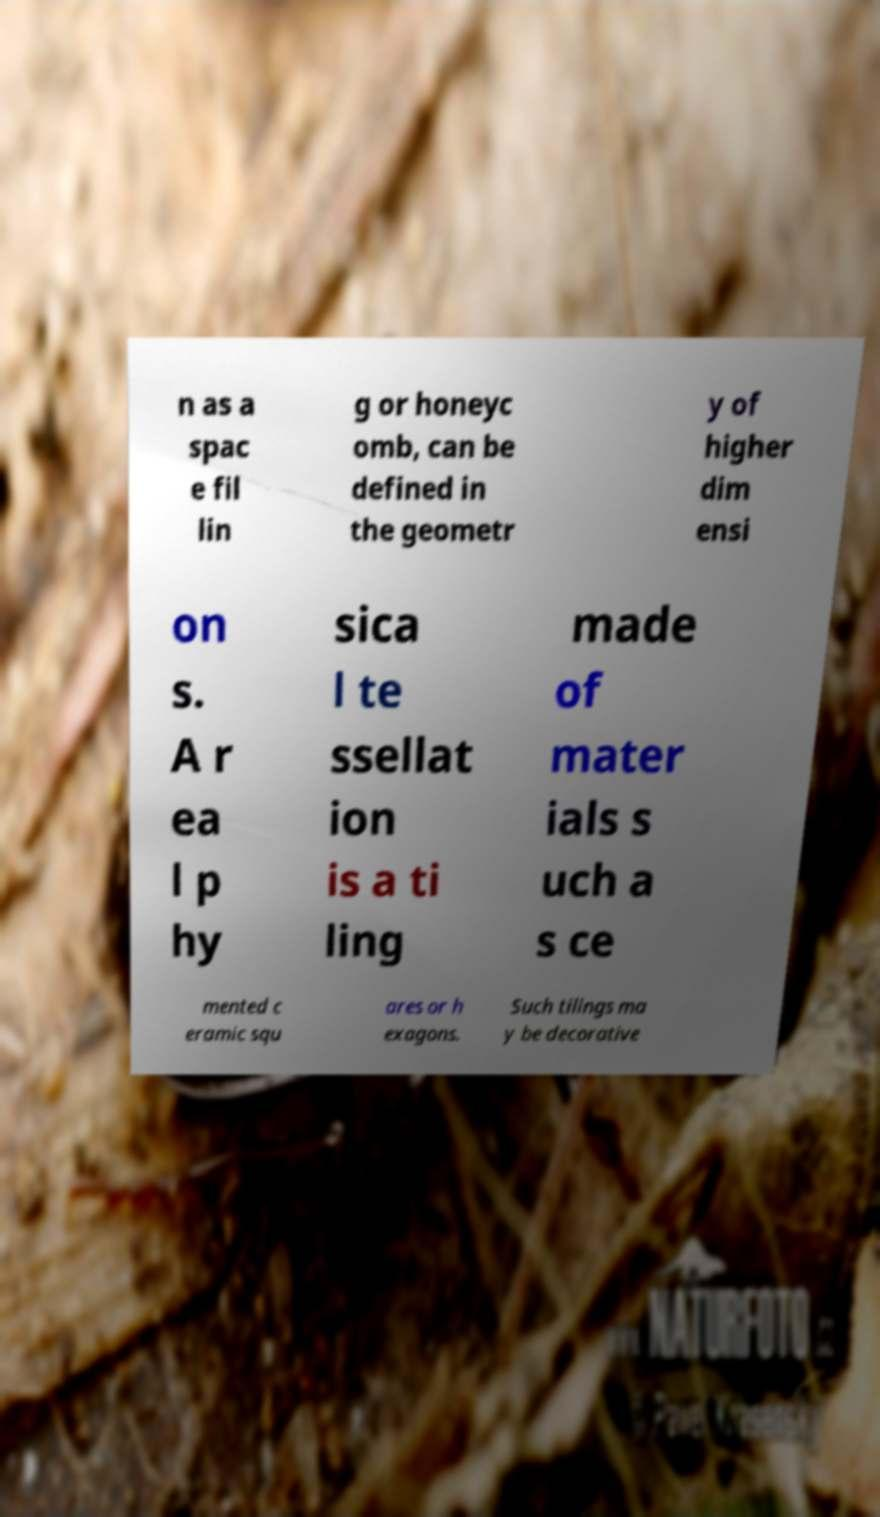Can you accurately transcribe the text from the provided image for me? n as a spac e fil lin g or honeyc omb, can be defined in the geometr y of higher dim ensi on s. A r ea l p hy sica l te ssellat ion is a ti ling made of mater ials s uch a s ce mented c eramic squ ares or h exagons. Such tilings ma y be decorative 